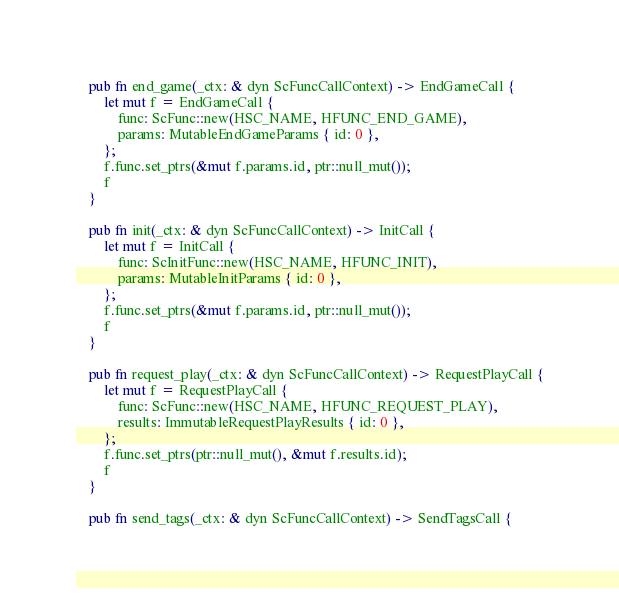Convert code to text. <code><loc_0><loc_0><loc_500><loc_500><_Rust_>
    pub fn end_game(_ctx: & dyn ScFuncCallContext) -> EndGameCall {
        let mut f = EndGameCall {
            func: ScFunc::new(HSC_NAME, HFUNC_END_GAME),
            params: MutableEndGameParams { id: 0 },
        };
        f.func.set_ptrs(&mut f.params.id, ptr::null_mut());
        f
    }

    pub fn init(_ctx: & dyn ScFuncCallContext) -> InitCall {
        let mut f = InitCall {
            func: ScInitFunc::new(HSC_NAME, HFUNC_INIT),
            params: MutableInitParams { id: 0 },
        };
        f.func.set_ptrs(&mut f.params.id, ptr::null_mut());
        f
    }

    pub fn request_play(_ctx: & dyn ScFuncCallContext) -> RequestPlayCall {
        let mut f = RequestPlayCall {
            func: ScFunc::new(HSC_NAME, HFUNC_REQUEST_PLAY),
            results: ImmutableRequestPlayResults { id: 0 },
        };
        f.func.set_ptrs(ptr::null_mut(), &mut f.results.id);
        f
    }

    pub fn send_tags(_ctx: & dyn ScFuncCallContext) -> SendTagsCall {</code> 